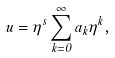Convert formula to latex. <formula><loc_0><loc_0><loc_500><loc_500>u = \eta ^ { s } \sum _ { k = 0 } ^ { \infty } a _ { k } \eta ^ { k } ,</formula> 